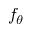<formula> <loc_0><loc_0><loc_500><loc_500>f _ { \theta }</formula> 